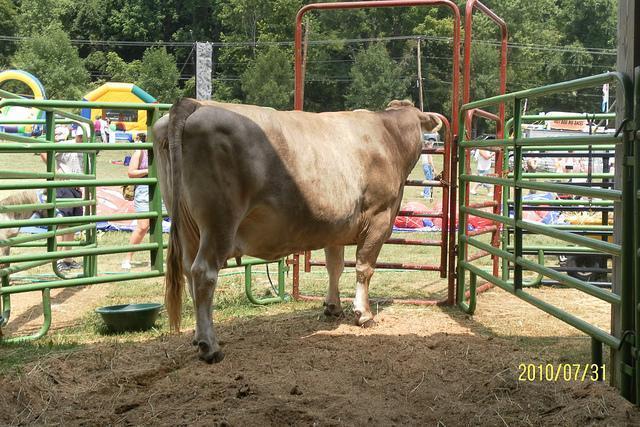How many elephants are standing up in the water?
Give a very brief answer. 0. 